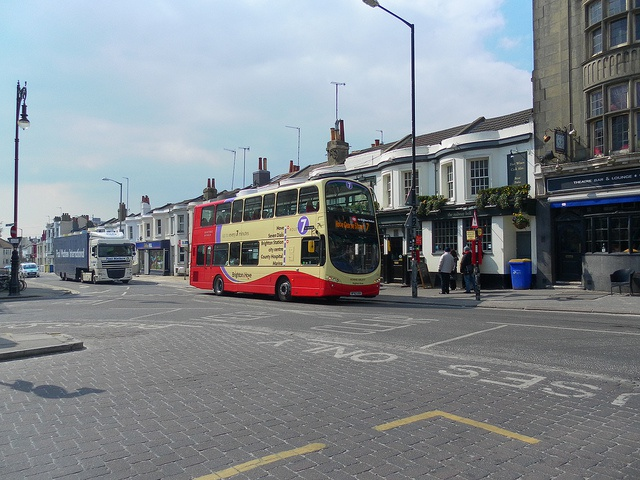Describe the objects in this image and their specific colors. I can see bus in lightblue, black, gray, khaki, and brown tones, truck in lightblue, gray, darkgray, black, and navy tones, potted plant in lightblue, black, gray, and darkgreen tones, people in lightblue, black, gray, and lightgray tones, and chair in lightblue, black, gray, and purple tones in this image. 